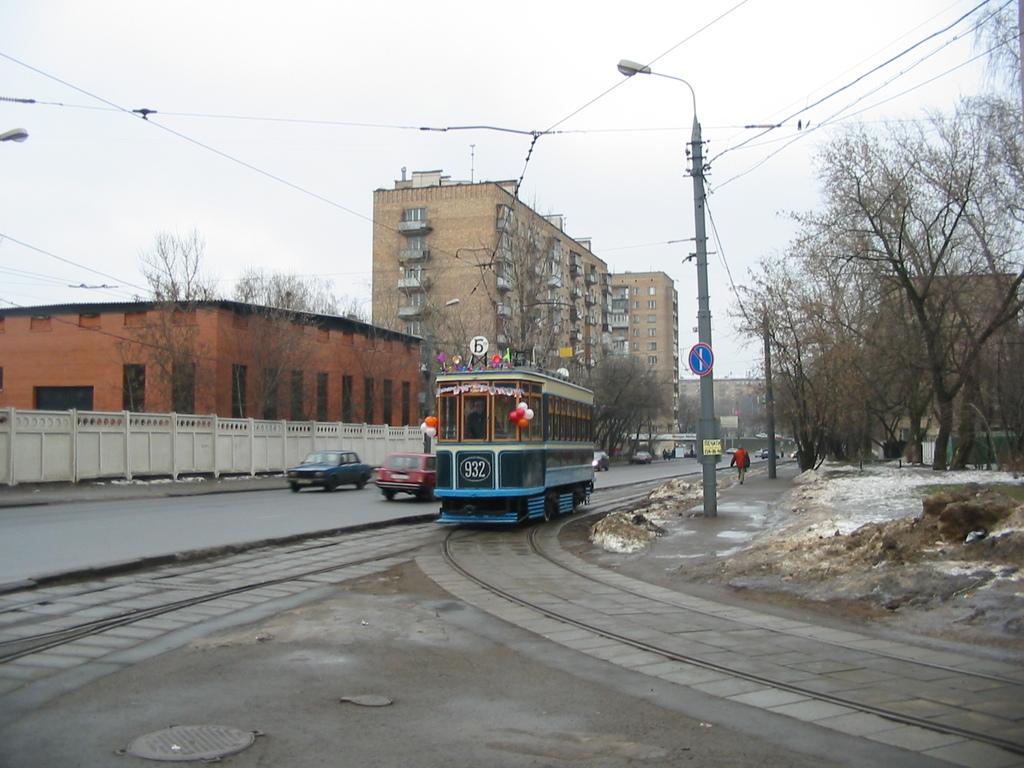What is the number on the tram?
Offer a very short reply. 932. 